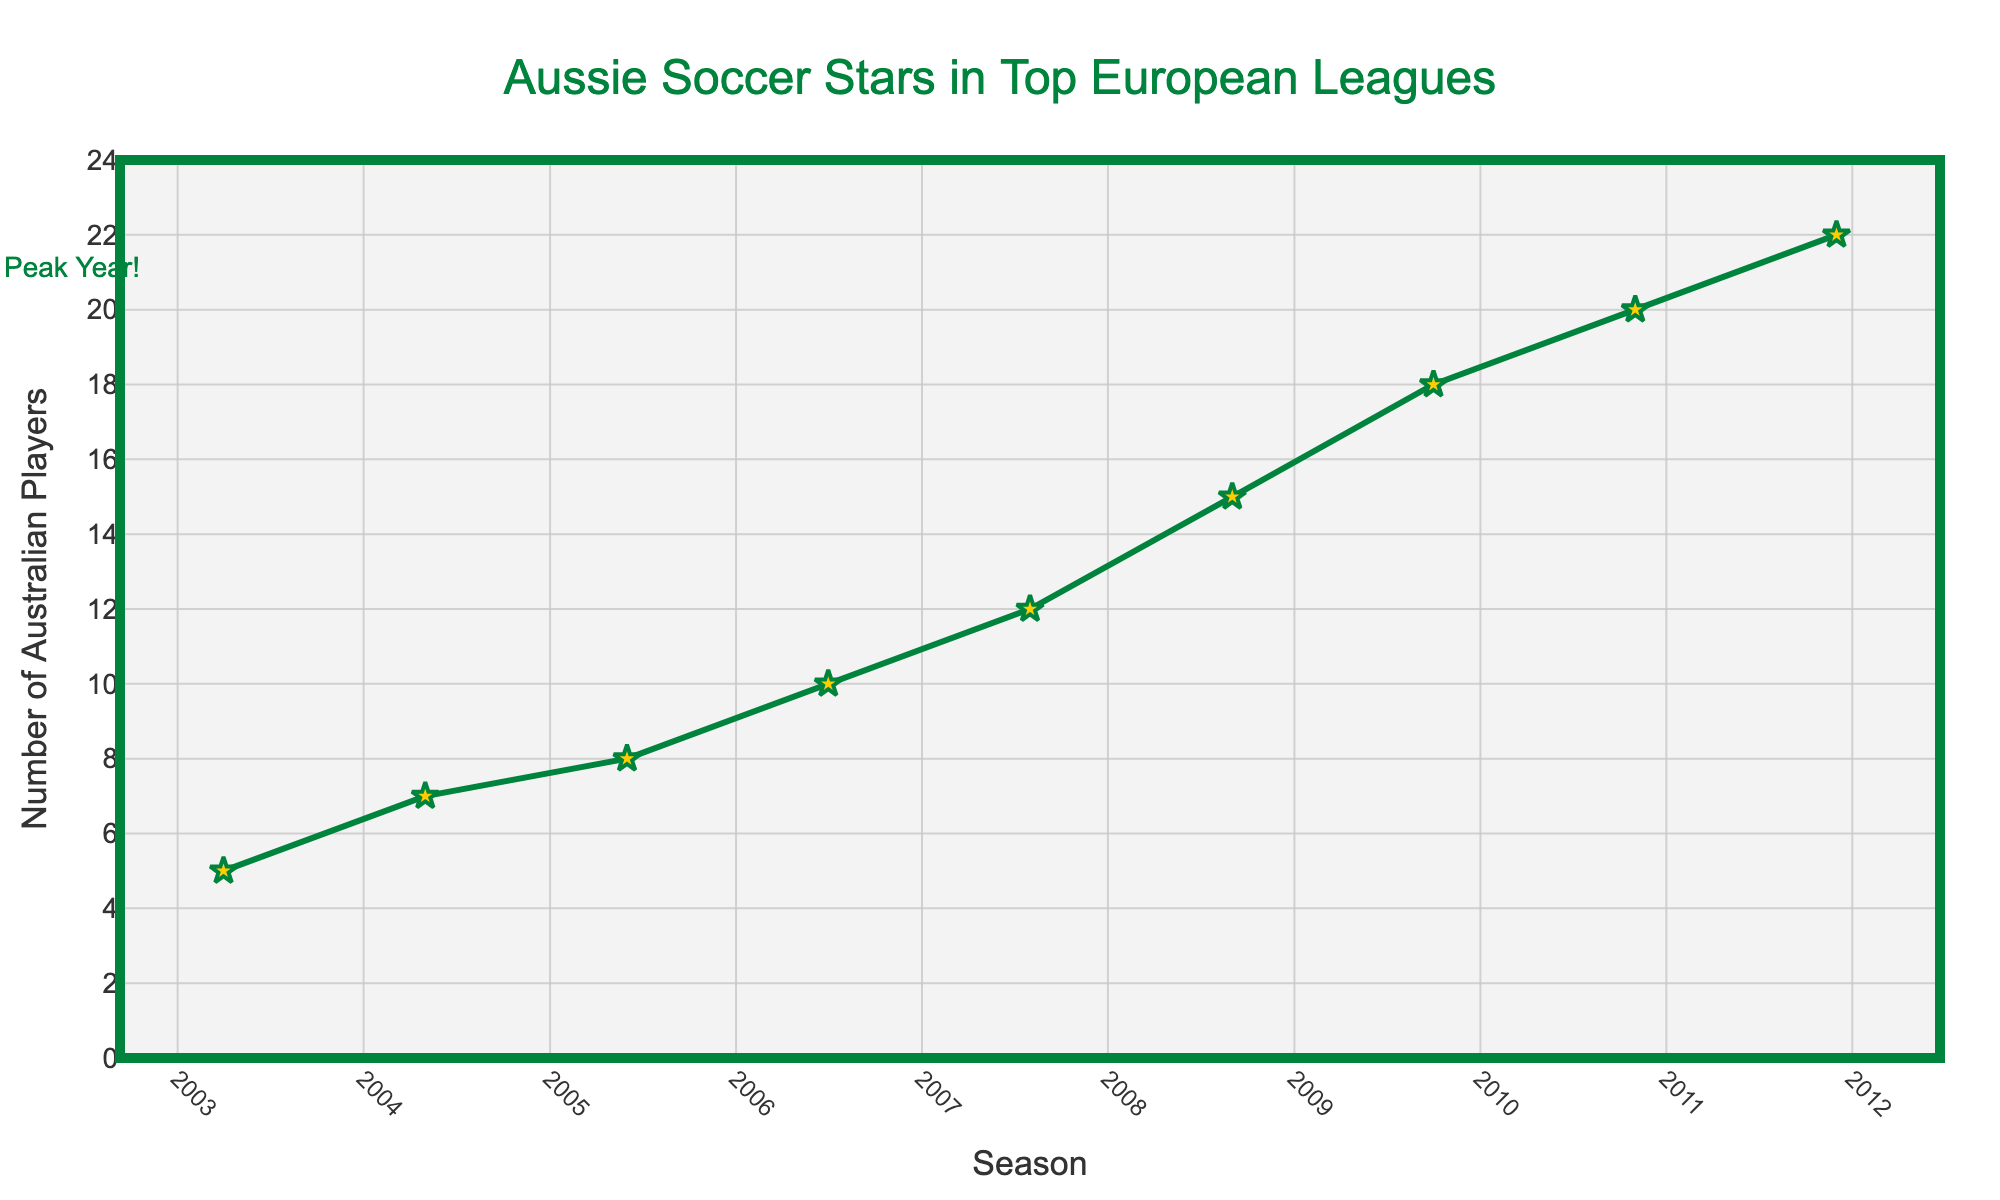What's the peak number of Australian players in top European leagues? Look at the highest point in the plot where the number of players is the highest, which is clearly marked with an annotation. In the 2012-13 season, there are 22 Australian players.
Answer: 22 In which season did the number of Australian players first reach double digits? Check the plot for the earliest season where the number of players hits 10 or more. This happens in the 2006-07 season.
Answer: 2006-07 How many Australian players were there in the top European leagues in the 2007-08 season compared to the 2019-20 season? Look at the values for both these seasons on the x-axis: 12 players in 2007-08 and 9 players in 2019-20. Compare the two numbers directly.
Answer: 12 in 2007-08, 9 in 2019-20 Which season had a lower number of Australian players: the 2021-22 season or the 2008-09 season? Check the values for these seasons on the x-axis: 10 players in 2021-22 and 15 players in 2008-09. The 2021-22 season had fewer players.
Answer: 2021-22 What’s the difference in the number of Australian players between the 2010-11 and 2013-14 seasons? Find the values for these seasons: 20 players in 2010-11 and 17 players in 2013-14. Subtract the latter from the former to find the difference (20 - 17).
Answer: 3 How did the number of players change from the 2011-12 season to the 2014-15 season? Observe the values: 22 players in 2011-12, decreasing to 15 players in 2014-15. The change is a decrease of 7 players (22 - 15).
Answer: Decreased by 7 What’s the average number of Australian players from the 2003-04 season to the 2022-23 season? Sum the numbers for all seasons: (5 + 7 + 8 + 10 + 12 + 15 + 18 + 20 + 22 + 19 + 17 + 15 + 14 + 13 + 11 + 10 + 9 + 8 + 10 + 12). There are 20 seasons in total. Average = Total/20 = 255/20.
Answer: 12.75 Which season had the lowest number of Australian players? Check the lowest point on the graph. The lowest value is 5 in the 2003-04 season.
Answer: 2003-04 How does the number of Australian players in the 2022-23 season compare to the peak in the 2012-13 season? Compare the values: 12 players in 2022-23 and 22 players in 2012-13. The 2022-23 season has 10 fewer players.
Answer: 10 fewer Identify two consecutive seasons where the number of Australian players remained the same. Look for two adjacent points on the graph with the same values. From 2018-19 to 2019-20, the values are both 10.
Answer: 2018-19 and 2019-20 